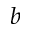<formula> <loc_0><loc_0><loc_500><loc_500>b</formula> 